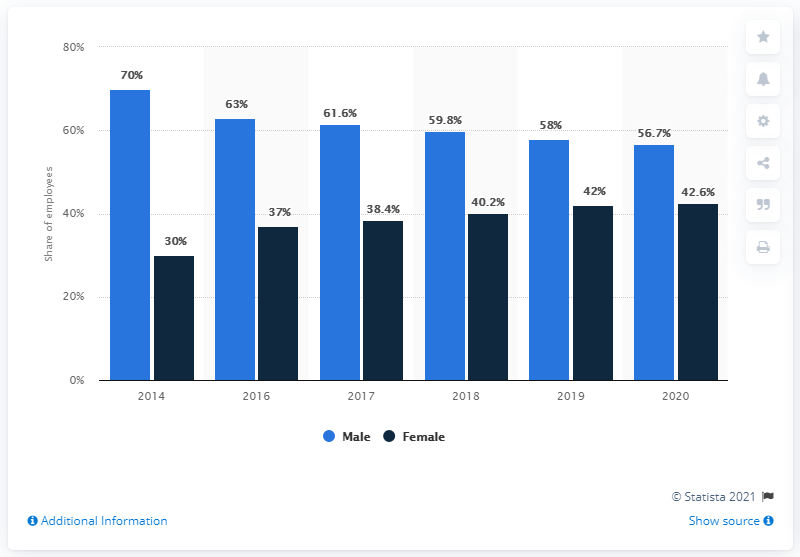List a handful of essential elements in this visual. In 2020, the smallest difference between the number of male and female employees was observed. The light blue bars are consistently taller than the dark blue bars across all years, indicating a trend of increasing height over time. 